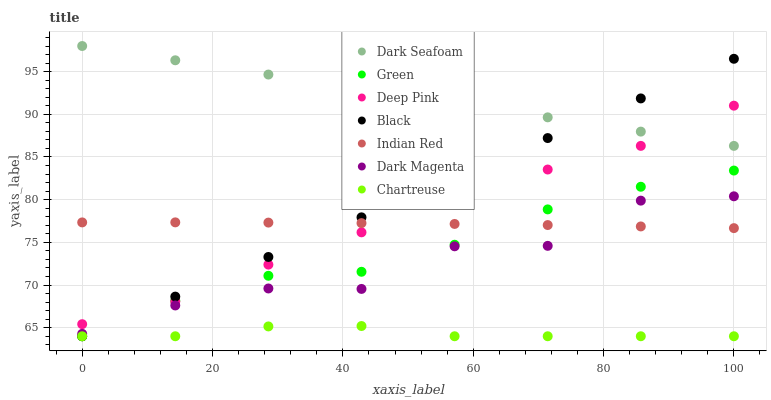Does Chartreuse have the minimum area under the curve?
Answer yes or no. Yes. Does Dark Seafoam have the maximum area under the curve?
Answer yes or no. Yes. Does Dark Magenta have the minimum area under the curve?
Answer yes or no. No. Does Dark Magenta have the maximum area under the curve?
Answer yes or no. No. Is Black the smoothest?
Answer yes or no. Yes. Is Dark Magenta the roughest?
Answer yes or no. Yes. Is Chartreuse the smoothest?
Answer yes or no. No. Is Chartreuse the roughest?
Answer yes or no. No. Does Chartreuse have the lowest value?
Answer yes or no. Yes. Does Dark Magenta have the lowest value?
Answer yes or no. No. Does Dark Seafoam have the highest value?
Answer yes or no. Yes. Does Dark Magenta have the highest value?
Answer yes or no. No. Is Chartreuse less than Dark Magenta?
Answer yes or no. Yes. Is Deep Pink greater than Dark Magenta?
Answer yes or no. Yes. Does Dark Seafoam intersect Deep Pink?
Answer yes or no. Yes. Is Dark Seafoam less than Deep Pink?
Answer yes or no. No. Is Dark Seafoam greater than Deep Pink?
Answer yes or no. No. Does Chartreuse intersect Dark Magenta?
Answer yes or no. No. 